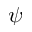<formula> <loc_0><loc_0><loc_500><loc_500>\psi</formula> 